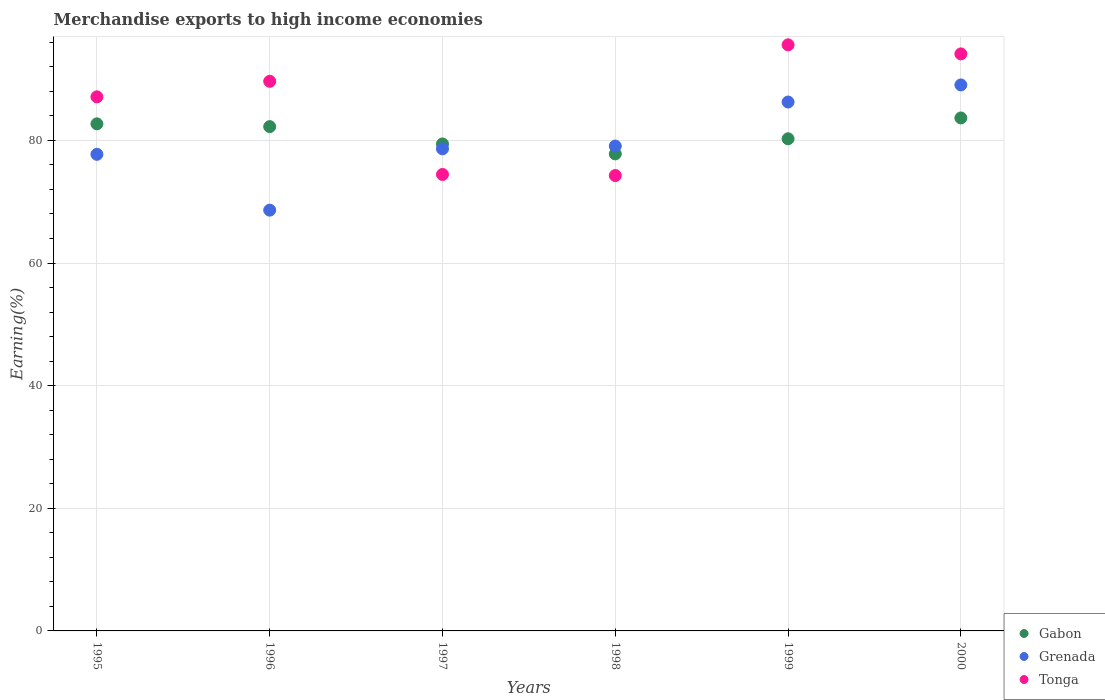How many different coloured dotlines are there?
Make the answer very short. 3. What is the percentage of amount earned from merchandise exports in Grenada in 1998?
Your answer should be very brief. 79.08. Across all years, what is the maximum percentage of amount earned from merchandise exports in Tonga?
Give a very brief answer. 95.59. Across all years, what is the minimum percentage of amount earned from merchandise exports in Tonga?
Provide a short and direct response. 74.27. In which year was the percentage of amount earned from merchandise exports in Grenada maximum?
Offer a very short reply. 2000. What is the total percentage of amount earned from merchandise exports in Tonga in the graph?
Provide a short and direct response. 515.17. What is the difference between the percentage of amount earned from merchandise exports in Gabon in 1995 and that in 1999?
Give a very brief answer. 2.44. What is the difference between the percentage of amount earned from merchandise exports in Gabon in 1998 and the percentage of amount earned from merchandise exports in Tonga in 1995?
Offer a terse response. -9.31. What is the average percentage of amount earned from merchandise exports in Grenada per year?
Keep it short and to the point. 79.9. In the year 2000, what is the difference between the percentage of amount earned from merchandise exports in Gabon and percentage of amount earned from merchandise exports in Tonga?
Provide a succinct answer. -10.45. In how many years, is the percentage of amount earned from merchandise exports in Tonga greater than 80 %?
Your answer should be very brief. 4. What is the ratio of the percentage of amount earned from merchandise exports in Tonga in 1995 to that in 2000?
Offer a very short reply. 0.93. Is the difference between the percentage of amount earned from merchandise exports in Gabon in 1997 and 1998 greater than the difference between the percentage of amount earned from merchandise exports in Tonga in 1997 and 1998?
Give a very brief answer. Yes. What is the difference between the highest and the second highest percentage of amount earned from merchandise exports in Tonga?
Your answer should be very brief. 1.48. What is the difference between the highest and the lowest percentage of amount earned from merchandise exports in Gabon?
Ensure brevity in your answer.  5.86. Is the percentage of amount earned from merchandise exports in Gabon strictly less than the percentage of amount earned from merchandise exports in Grenada over the years?
Your answer should be very brief. No. How many dotlines are there?
Your answer should be very brief. 3. How many years are there in the graph?
Keep it short and to the point. 6. What is the difference between two consecutive major ticks on the Y-axis?
Your answer should be very brief. 20. Does the graph contain any zero values?
Your response must be concise. No. Where does the legend appear in the graph?
Your answer should be very brief. Bottom right. What is the title of the graph?
Make the answer very short. Merchandise exports to high income economies. Does "Virgin Islands" appear as one of the legend labels in the graph?
Keep it short and to the point. No. What is the label or title of the Y-axis?
Provide a short and direct response. Earning(%). What is the Earning(%) of Gabon in 1995?
Provide a short and direct response. 82.7. What is the Earning(%) in Grenada in 1995?
Keep it short and to the point. 77.73. What is the Earning(%) of Tonga in 1995?
Make the answer very short. 87.11. What is the Earning(%) in Gabon in 1996?
Your answer should be compact. 82.25. What is the Earning(%) of Grenada in 1996?
Offer a terse response. 68.63. What is the Earning(%) of Tonga in 1996?
Your answer should be compact. 89.64. What is the Earning(%) of Gabon in 1997?
Provide a succinct answer. 79.42. What is the Earning(%) in Grenada in 1997?
Offer a very short reply. 78.63. What is the Earning(%) of Tonga in 1997?
Make the answer very short. 74.45. What is the Earning(%) in Gabon in 1998?
Offer a very short reply. 77.8. What is the Earning(%) in Grenada in 1998?
Your answer should be compact. 79.08. What is the Earning(%) of Tonga in 1998?
Provide a succinct answer. 74.27. What is the Earning(%) of Gabon in 1999?
Your answer should be very brief. 80.27. What is the Earning(%) of Grenada in 1999?
Keep it short and to the point. 86.26. What is the Earning(%) of Tonga in 1999?
Keep it short and to the point. 95.59. What is the Earning(%) of Gabon in 2000?
Give a very brief answer. 83.66. What is the Earning(%) of Grenada in 2000?
Offer a terse response. 89.05. What is the Earning(%) in Tonga in 2000?
Your answer should be very brief. 94.11. Across all years, what is the maximum Earning(%) in Gabon?
Make the answer very short. 83.66. Across all years, what is the maximum Earning(%) of Grenada?
Your answer should be very brief. 89.05. Across all years, what is the maximum Earning(%) in Tonga?
Make the answer very short. 95.59. Across all years, what is the minimum Earning(%) of Gabon?
Give a very brief answer. 77.8. Across all years, what is the minimum Earning(%) in Grenada?
Give a very brief answer. 68.63. Across all years, what is the minimum Earning(%) in Tonga?
Your response must be concise. 74.27. What is the total Earning(%) in Gabon in the graph?
Offer a very short reply. 486.11. What is the total Earning(%) in Grenada in the graph?
Provide a succinct answer. 479.38. What is the total Earning(%) of Tonga in the graph?
Provide a succinct answer. 515.17. What is the difference between the Earning(%) of Gabon in 1995 and that in 1996?
Give a very brief answer. 0.45. What is the difference between the Earning(%) of Grenada in 1995 and that in 1996?
Give a very brief answer. 9.11. What is the difference between the Earning(%) of Tonga in 1995 and that in 1996?
Provide a short and direct response. -2.54. What is the difference between the Earning(%) in Gabon in 1995 and that in 1997?
Give a very brief answer. 3.28. What is the difference between the Earning(%) in Grenada in 1995 and that in 1997?
Keep it short and to the point. -0.89. What is the difference between the Earning(%) in Tonga in 1995 and that in 1997?
Offer a terse response. 12.66. What is the difference between the Earning(%) of Gabon in 1995 and that in 1998?
Provide a short and direct response. 4.9. What is the difference between the Earning(%) in Grenada in 1995 and that in 1998?
Make the answer very short. -1.35. What is the difference between the Earning(%) in Tonga in 1995 and that in 1998?
Provide a short and direct response. 12.84. What is the difference between the Earning(%) of Gabon in 1995 and that in 1999?
Your answer should be compact. 2.44. What is the difference between the Earning(%) of Grenada in 1995 and that in 1999?
Your answer should be very brief. -8.53. What is the difference between the Earning(%) in Tonga in 1995 and that in 1999?
Ensure brevity in your answer.  -8.48. What is the difference between the Earning(%) of Gabon in 1995 and that in 2000?
Offer a very short reply. -0.96. What is the difference between the Earning(%) of Grenada in 1995 and that in 2000?
Provide a short and direct response. -11.32. What is the difference between the Earning(%) in Tonga in 1995 and that in 2000?
Make the answer very short. -7. What is the difference between the Earning(%) in Gabon in 1996 and that in 1997?
Your response must be concise. 2.83. What is the difference between the Earning(%) of Grenada in 1996 and that in 1997?
Your answer should be very brief. -10. What is the difference between the Earning(%) of Tonga in 1996 and that in 1997?
Offer a terse response. 15.2. What is the difference between the Earning(%) in Gabon in 1996 and that in 1998?
Keep it short and to the point. 4.45. What is the difference between the Earning(%) of Grenada in 1996 and that in 1998?
Provide a succinct answer. -10.45. What is the difference between the Earning(%) of Tonga in 1996 and that in 1998?
Keep it short and to the point. 15.37. What is the difference between the Earning(%) in Gabon in 1996 and that in 1999?
Your response must be concise. 1.98. What is the difference between the Earning(%) of Grenada in 1996 and that in 1999?
Keep it short and to the point. -17.63. What is the difference between the Earning(%) of Tonga in 1996 and that in 1999?
Your response must be concise. -5.94. What is the difference between the Earning(%) in Gabon in 1996 and that in 2000?
Make the answer very short. -1.41. What is the difference between the Earning(%) in Grenada in 1996 and that in 2000?
Provide a succinct answer. -20.42. What is the difference between the Earning(%) of Tonga in 1996 and that in 2000?
Your answer should be very brief. -4.47. What is the difference between the Earning(%) in Gabon in 1997 and that in 1998?
Your answer should be compact. 1.62. What is the difference between the Earning(%) of Grenada in 1997 and that in 1998?
Make the answer very short. -0.45. What is the difference between the Earning(%) in Tonga in 1997 and that in 1998?
Provide a succinct answer. 0.17. What is the difference between the Earning(%) in Gabon in 1997 and that in 1999?
Make the answer very short. -0.84. What is the difference between the Earning(%) of Grenada in 1997 and that in 1999?
Provide a succinct answer. -7.63. What is the difference between the Earning(%) of Tonga in 1997 and that in 1999?
Your answer should be very brief. -21.14. What is the difference between the Earning(%) in Gabon in 1997 and that in 2000?
Your response must be concise. -4.24. What is the difference between the Earning(%) of Grenada in 1997 and that in 2000?
Your answer should be compact. -10.42. What is the difference between the Earning(%) of Tonga in 1997 and that in 2000?
Provide a succinct answer. -19.67. What is the difference between the Earning(%) in Gabon in 1998 and that in 1999?
Provide a short and direct response. -2.47. What is the difference between the Earning(%) in Grenada in 1998 and that in 1999?
Offer a terse response. -7.18. What is the difference between the Earning(%) of Tonga in 1998 and that in 1999?
Your answer should be compact. -21.32. What is the difference between the Earning(%) of Gabon in 1998 and that in 2000?
Keep it short and to the point. -5.86. What is the difference between the Earning(%) in Grenada in 1998 and that in 2000?
Your answer should be compact. -9.97. What is the difference between the Earning(%) of Tonga in 1998 and that in 2000?
Make the answer very short. -19.84. What is the difference between the Earning(%) in Gabon in 1999 and that in 2000?
Offer a terse response. -3.39. What is the difference between the Earning(%) of Grenada in 1999 and that in 2000?
Your answer should be very brief. -2.79. What is the difference between the Earning(%) in Tonga in 1999 and that in 2000?
Keep it short and to the point. 1.48. What is the difference between the Earning(%) in Gabon in 1995 and the Earning(%) in Grenada in 1996?
Offer a terse response. 14.08. What is the difference between the Earning(%) of Gabon in 1995 and the Earning(%) of Tonga in 1996?
Provide a succinct answer. -6.94. What is the difference between the Earning(%) in Grenada in 1995 and the Earning(%) in Tonga in 1996?
Offer a terse response. -11.91. What is the difference between the Earning(%) in Gabon in 1995 and the Earning(%) in Grenada in 1997?
Your answer should be very brief. 4.08. What is the difference between the Earning(%) in Gabon in 1995 and the Earning(%) in Tonga in 1997?
Your answer should be very brief. 8.26. What is the difference between the Earning(%) of Grenada in 1995 and the Earning(%) of Tonga in 1997?
Your response must be concise. 3.29. What is the difference between the Earning(%) in Gabon in 1995 and the Earning(%) in Grenada in 1998?
Keep it short and to the point. 3.62. What is the difference between the Earning(%) in Gabon in 1995 and the Earning(%) in Tonga in 1998?
Ensure brevity in your answer.  8.43. What is the difference between the Earning(%) of Grenada in 1995 and the Earning(%) of Tonga in 1998?
Offer a very short reply. 3.46. What is the difference between the Earning(%) of Gabon in 1995 and the Earning(%) of Grenada in 1999?
Provide a succinct answer. -3.56. What is the difference between the Earning(%) of Gabon in 1995 and the Earning(%) of Tonga in 1999?
Give a very brief answer. -12.88. What is the difference between the Earning(%) of Grenada in 1995 and the Earning(%) of Tonga in 1999?
Your response must be concise. -17.86. What is the difference between the Earning(%) of Gabon in 1995 and the Earning(%) of Grenada in 2000?
Offer a very short reply. -6.34. What is the difference between the Earning(%) in Gabon in 1995 and the Earning(%) in Tonga in 2000?
Keep it short and to the point. -11.41. What is the difference between the Earning(%) in Grenada in 1995 and the Earning(%) in Tonga in 2000?
Make the answer very short. -16.38. What is the difference between the Earning(%) in Gabon in 1996 and the Earning(%) in Grenada in 1997?
Your answer should be compact. 3.62. What is the difference between the Earning(%) in Gabon in 1996 and the Earning(%) in Tonga in 1997?
Provide a short and direct response. 7.8. What is the difference between the Earning(%) of Grenada in 1996 and the Earning(%) of Tonga in 1997?
Offer a terse response. -5.82. What is the difference between the Earning(%) in Gabon in 1996 and the Earning(%) in Grenada in 1998?
Your response must be concise. 3.17. What is the difference between the Earning(%) of Gabon in 1996 and the Earning(%) of Tonga in 1998?
Your answer should be very brief. 7.98. What is the difference between the Earning(%) of Grenada in 1996 and the Earning(%) of Tonga in 1998?
Provide a succinct answer. -5.65. What is the difference between the Earning(%) in Gabon in 1996 and the Earning(%) in Grenada in 1999?
Your response must be concise. -4.01. What is the difference between the Earning(%) of Gabon in 1996 and the Earning(%) of Tonga in 1999?
Make the answer very short. -13.34. What is the difference between the Earning(%) of Grenada in 1996 and the Earning(%) of Tonga in 1999?
Your answer should be compact. -26.96. What is the difference between the Earning(%) of Gabon in 1996 and the Earning(%) of Grenada in 2000?
Ensure brevity in your answer.  -6.8. What is the difference between the Earning(%) of Gabon in 1996 and the Earning(%) of Tonga in 2000?
Keep it short and to the point. -11.86. What is the difference between the Earning(%) of Grenada in 1996 and the Earning(%) of Tonga in 2000?
Provide a succinct answer. -25.49. What is the difference between the Earning(%) of Gabon in 1997 and the Earning(%) of Grenada in 1998?
Keep it short and to the point. 0.34. What is the difference between the Earning(%) of Gabon in 1997 and the Earning(%) of Tonga in 1998?
Keep it short and to the point. 5.15. What is the difference between the Earning(%) in Grenada in 1997 and the Earning(%) in Tonga in 1998?
Keep it short and to the point. 4.35. What is the difference between the Earning(%) of Gabon in 1997 and the Earning(%) of Grenada in 1999?
Your answer should be very brief. -6.84. What is the difference between the Earning(%) in Gabon in 1997 and the Earning(%) in Tonga in 1999?
Ensure brevity in your answer.  -16.16. What is the difference between the Earning(%) of Grenada in 1997 and the Earning(%) of Tonga in 1999?
Your answer should be very brief. -16.96. What is the difference between the Earning(%) in Gabon in 1997 and the Earning(%) in Grenada in 2000?
Offer a terse response. -9.62. What is the difference between the Earning(%) in Gabon in 1997 and the Earning(%) in Tonga in 2000?
Ensure brevity in your answer.  -14.69. What is the difference between the Earning(%) of Grenada in 1997 and the Earning(%) of Tonga in 2000?
Make the answer very short. -15.48. What is the difference between the Earning(%) of Gabon in 1998 and the Earning(%) of Grenada in 1999?
Make the answer very short. -8.46. What is the difference between the Earning(%) in Gabon in 1998 and the Earning(%) in Tonga in 1999?
Provide a succinct answer. -17.79. What is the difference between the Earning(%) of Grenada in 1998 and the Earning(%) of Tonga in 1999?
Your response must be concise. -16.51. What is the difference between the Earning(%) in Gabon in 1998 and the Earning(%) in Grenada in 2000?
Your answer should be compact. -11.25. What is the difference between the Earning(%) in Gabon in 1998 and the Earning(%) in Tonga in 2000?
Your answer should be very brief. -16.31. What is the difference between the Earning(%) of Grenada in 1998 and the Earning(%) of Tonga in 2000?
Make the answer very short. -15.03. What is the difference between the Earning(%) in Gabon in 1999 and the Earning(%) in Grenada in 2000?
Provide a succinct answer. -8.78. What is the difference between the Earning(%) of Gabon in 1999 and the Earning(%) of Tonga in 2000?
Your answer should be very brief. -13.84. What is the difference between the Earning(%) of Grenada in 1999 and the Earning(%) of Tonga in 2000?
Keep it short and to the point. -7.85. What is the average Earning(%) in Gabon per year?
Make the answer very short. 81.02. What is the average Earning(%) of Grenada per year?
Offer a very short reply. 79.9. What is the average Earning(%) in Tonga per year?
Your answer should be very brief. 85.86. In the year 1995, what is the difference between the Earning(%) of Gabon and Earning(%) of Grenada?
Provide a succinct answer. 4.97. In the year 1995, what is the difference between the Earning(%) of Gabon and Earning(%) of Tonga?
Make the answer very short. -4.4. In the year 1995, what is the difference between the Earning(%) of Grenada and Earning(%) of Tonga?
Offer a very short reply. -9.38. In the year 1996, what is the difference between the Earning(%) of Gabon and Earning(%) of Grenada?
Your answer should be very brief. 13.63. In the year 1996, what is the difference between the Earning(%) in Gabon and Earning(%) in Tonga?
Provide a succinct answer. -7.39. In the year 1996, what is the difference between the Earning(%) of Grenada and Earning(%) of Tonga?
Your answer should be compact. -21.02. In the year 1997, what is the difference between the Earning(%) in Gabon and Earning(%) in Grenada?
Your answer should be very brief. 0.8. In the year 1997, what is the difference between the Earning(%) of Gabon and Earning(%) of Tonga?
Keep it short and to the point. 4.98. In the year 1997, what is the difference between the Earning(%) in Grenada and Earning(%) in Tonga?
Ensure brevity in your answer.  4.18. In the year 1998, what is the difference between the Earning(%) of Gabon and Earning(%) of Grenada?
Your response must be concise. -1.28. In the year 1998, what is the difference between the Earning(%) in Gabon and Earning(%) in Tonga?
Ensure brevity in your answer.  3.53. In the year 1998, what is the difference between the Earning(%) of Grenada and Earning(%) of Tonga?
Your answer should be compact. 4.81. In the year 1999, what is the difference between the Earning(%) of Gabon and Earning(%) of Grenada?
Keep it short and to the point. -5.99. In the year 1999, what is the difference between the Earning(%) of Gabon and Earning(%) of Tonga?
Your answer should be compact. -15.32. In the year 1999, what is the difference between the Earning(%) in Grenada and Earning(%) in Tonga?
Your answer should be compact. -9.33. In the year 2000, what is the difference between the Earning(%) of Gabon and Earning(%) of Grenada?
Make the answer very short. -5.38. In the year 2000, what is the difference between the Earning(%) of Gabon and Earning(%) of Tonga?
Your answer should be very brief. -10.45. In the year 2000, what is the difference between the Earning(%) in Grenada and Earning(%) in Tonga?
Your response must be concise. -5.06. What is the ratio of the Earning(%) in Grenada in 1995 to that in 1996?
Provide a short and direct response. 1.13. What is the ratio of the Earning(%) in Tonga in 1995 to that in 1996?
Offer a very short reply. 0.97. What is the ratio of the Earning(%) of Gabon in 1995 to that in 1997?
Make the answer very short. 1.04. What is the ratio of the Earning(%) of Grenada in 1995 to that in 1997?
Provide a short and direct response. 0.99. What is the ratio of the Earning(%) in Tonga in 1995 to that in 1997?
Provide a short and direct response. 1.17. What is the ratio of the Earning(%) in Gabon in 1995 to that in 1998?
Offer a very short reply. 1.06. What is the ratio of the Earning(%) in Tonga in 1995 to that in 1998?
Your response must be concise. 1.17. What is the ratio of the Earning(%) in Gabon in 1995 to that in 1999?
Your answer should be very brief. 1.03. What is the ratio of the Earning(%) of Grenada in 1995 to that in 1999?
Ensure brevity in your answer.  0.9. What is the ratio of the Earning(%) in Tonga in 1995 to that in 1999?
Provide a succinct answer. 0.91. What is the ratio of the Earning(%) of Gabon in 1995 to that in 2000?
Ensure brevity in your answer.  0.99. What is the ratio of the Earning(%) of Grenada in 1995 to that in 2000?
Provide a succinct answer. 0.87. What is the ratio of the Earning(%) of Tonga in 1995 to that in 2000?
Make the answer very short. 0.93. What is the ratio of the Earning(%) in Gabon in 1996 to that in 1997?
Offer a very short reply. 1.04. What is the ratio of the Earning(%) of Grenada in 1996 to that in 1997?
Provide a succinct answer. 0.87. What is the ratio of the Earning(%) in Tonga in 1996 to that in 1997?
Give a very brief answer. 1.2. What is the ratio of the Earning(%) in Gabon in 1996 to that in 1998?
Provide a short and direct response. 1.06. What is the ratio of the Earning(%) in Grenada in 1996 to that in 1998?
Offer a very short reply. 0.87. What is the ratio of the Earning(%) of Tonga in 1996 to that in 1998?
Your response must be concise. 1.21. What is the ratio of the Earning(%) of Gabon in 1996 to that in 1999?
Provide a succinct answer. 1.02. What is the ratio of the Earning(%) in Grenada in 1996 to that in 1999?
Your answer should be very brief. 0.8. What is the ratio of the Earning(%) of Tonga in 1996 to that in 1999?
Offer a very short reply. 0.94. What is the ratio of the Earning(%) in Gabon in 1996 to that in 2000?
Make the answer very short. 0.98. What is the ratio of the Earning(%) of Grenada in 1996 to that in 2000?
Ensure brevity in your answer.  0.77. What is the ratio of the Earning(%) of Tonga in 1996 to that in 2000?
Offer a very short reply. 0.95. What is the ratio of the Earning(%) of Gabon in 1997 to that in 1998?
Offer a terse response. 1.02. What is the ratio of the Earning(%) in Gabon in 1997 to that in 1999?
Provide a succinct answer. 0.99. What is the ratio of the Earning(%) of Grenada in 1997 to that in 1999?
Your answer should be compact. 0.91. What is the ratio of the Earning(%) in Tonga in 1997 to that in 1999?
Ensure brevity in your answer.  0.78. What is the ratio of the Earning(%) of Gabon in 1997 to that in 2000?
Ensure brevity in your answer.  0.95. What is the ratio of the Earning(%) of Grenada in 1997 to that in 2000?
Offer a very short reply. 0.88. What is the ratio of the Earning(%) of Tonga in 1997 to that in 2000?
Ensure brevity in your answer.  0.79. What is the ratio of the Earning(%) of Gabon in 1998 to that in 1999?
Give a very brief answer. 0.97. What is the ratio of the Earning(%) in Grenada in 1998 to that in 1999?
Make the answer very short. 0.92. What is the ratio of the Earning(%) in Tonga in 1998 to that in 1999?
Provide a short and direct response. 0.78. What is the ratio of the Earning(%) of Gabon in 1998 to that in 2000?
Ensure brevity in your answer.  0.93. What is the ratio of the Earning(%) of Grenada in 1998 to that in 2000?
Ensure brevity in your answer.  0.89. What is the ratio of the Earning(%) of Tonga in 1998 to that in 2000?
Your answer should be very brief. 0.79. What is the ratio of the Earning(%) of Gabon in 1999 to that in 2000?
Offer a terse response. 0.96. What is the ratio of the Earning(%) of Grenada in 1999 to that in 2000?
Provide a short and direct response. 0.97. What is the ratio of the Earning(%) in Tonga in 1999 to that in 2000?
Offer a terse response. 1.02. What is the difference between the highest and the second highest Earning(%) of Gabon?
Give a very brief answer. 0.96. What is the difference between the highest and the second highest Earning(%) of Grenada?
Your answer should be compact. 2.79. What is the difference between the highest and the second highest Earning(%) of Tonga?
Give a very brief answer. 1.48. What is the difference between the highest and the lowest Earning(%) of Gabon?
Ensure brevity in your answer.  5.86. What is the difference between the highest and the lowest Earning(%) of Grenada?
Provide a succinct answer. 20.42. What is the difference between the highest and the lowest Earning(%) in Tonga?
Your answer should be very brief. 21.32. 